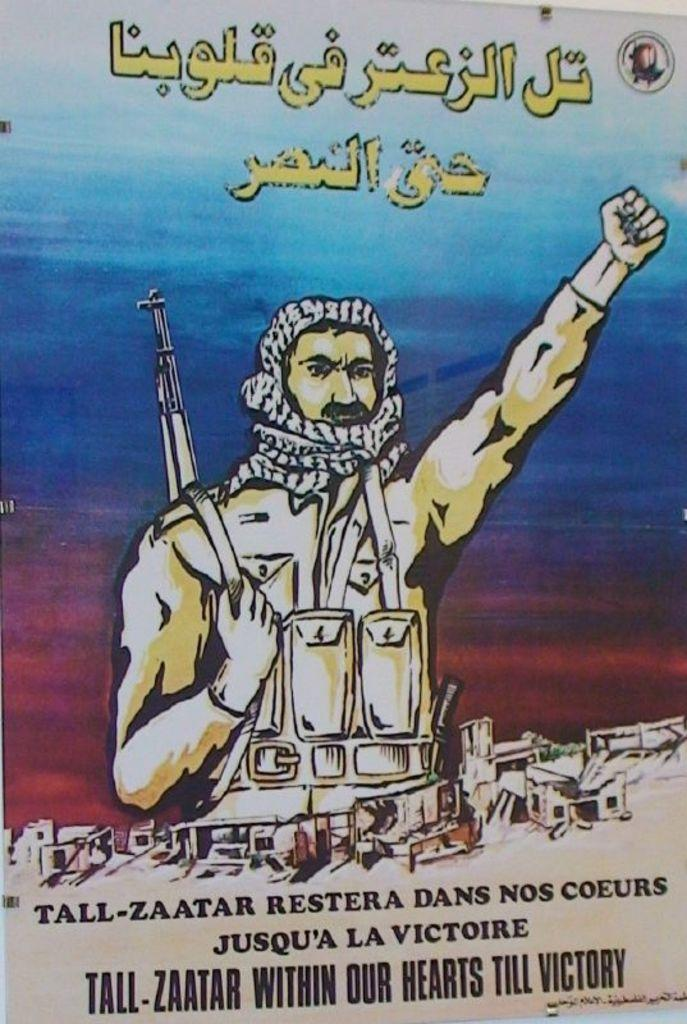What is featured in the picture? There is a poster in the picture. What can be seen on the poster? The poster has a depiction of a man. Are there any words on the poster? Yes, there is writing on the poster. Where is the kitten playing in the picture? There is no kitten present in the picture; it only features a poster with a depiction of a man and writing. 